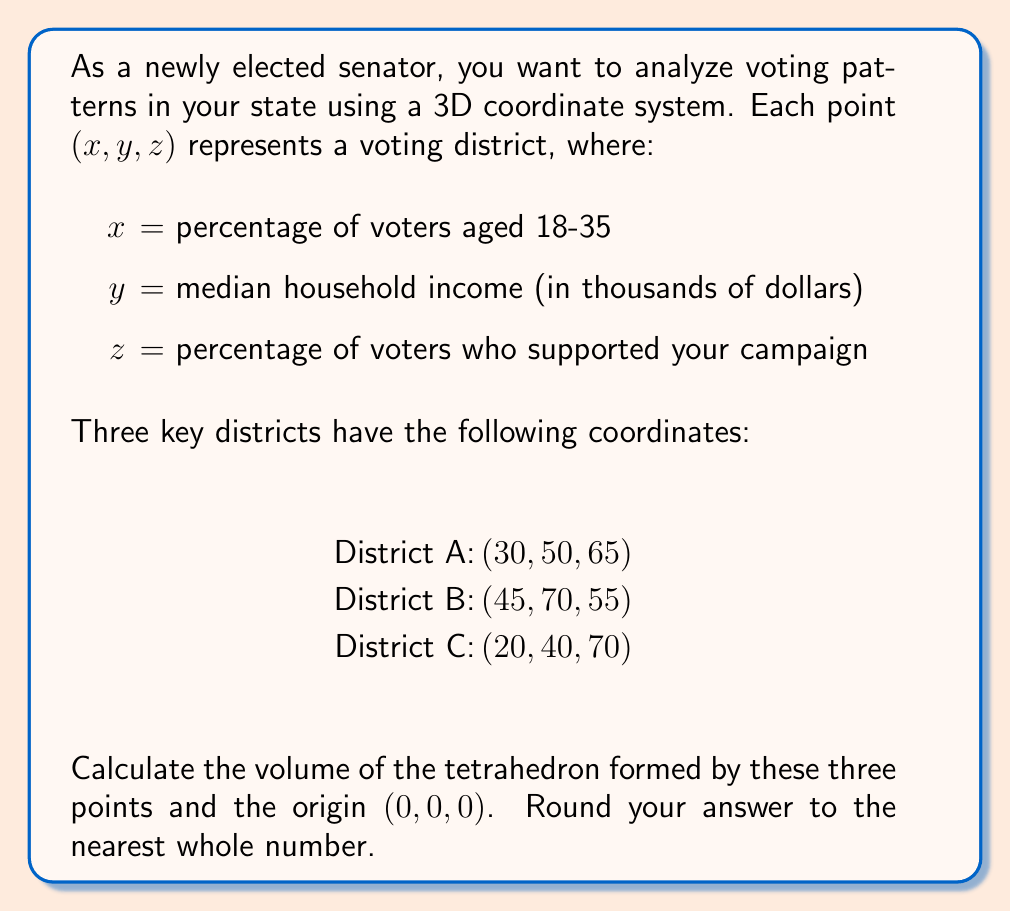Teach me how to tackle this problem. To solve this problem, we'll use the formula for the volume of a tetrahedron given the coordinates of its vertices. The steps are as follows:

1) The formula for the volume of a tetrahedron is:

   $$V = \frac{1}{6}|det(a-d, b-d, c-d)|$$

   where $a$, $b$, $c$, and $d$ are the position vectors of the four vertices.

2) In our case, let:
   $a = (30, 50, 65)$
   $b = (45, 70, 55)$
   $c = (20, 40, 70)$
   $d = (0, 0, 0)$ (origin)

3) Subtracting $d$ from each vector:
   $a-d = (30, 50, 65)$
   $b-d = (45, 70, 55)$
   $c-d = (20, 40, 70)$

4) Now we need to calculate the determinant:

   $$det = \begin{vmatrix} 
   30 & 50 & 65 \\
   45 & 70 & 55 \\
   20 & 40 & 70
   \end{vmatrix}$$

5) Expanding the determinant:
   $det = 30(70 \cdot 70 - 55 \cdot 40) - 50(45 \cdot 70 - 55 \cdot 20) + 65(45 \cdot 40 - 70 \cdot 20)$
   $    = 30(4900 - 2200) - 50(3150 - 1100) + 65(1800 - 1400)$
   $    = 30 \cdot 2700 - 50 \cdot 2050 + 65 \cdot 400$
   $    = 81000 - 102500 + 26000$
   $    = 4500$

6) The volume is $\frac{1}{6}$ of the absolute value of this determinant:

   $$V = \frac{1}{6}|4500| = 750$$

7) Rounding to the nearest whole number, we get 750.
Answer: 750 